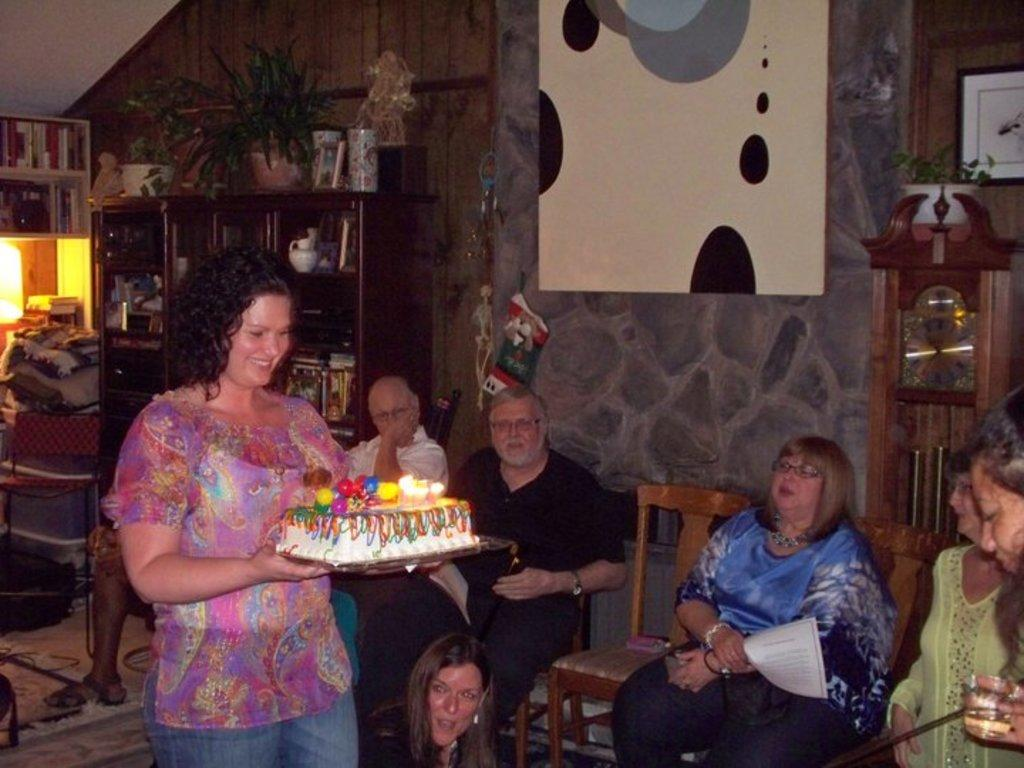What is the woman in the image holding? The woman is holding a cake. What are the people in the image doing? The people are sitting on chairs in the image. What can be seen on the rack in the image? There is a rack filled with things and a plant in the image, and there are books on the rack. What is on the wall in the image? There is a poster on the wall in the image. What historical event is being referenced in the caption of the poster in the image? There is no caption present on the poster in the image, so it is not possible to determine any historical reference. 